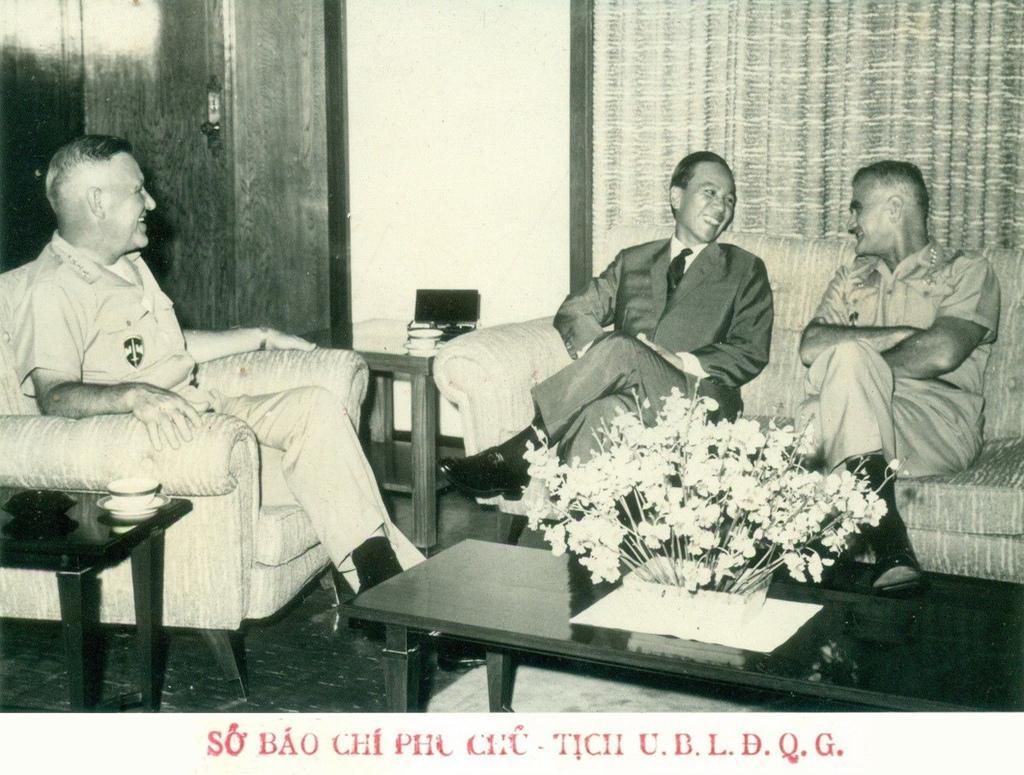Could you give a brief overview of what you see in this image? This picture is clicked inside a room. There are three men sitting on sofa chair. In front of them, we see a table on which flower pot is placed. To the left corner of this picture, we see a table on which cup and saucer is placed. In the middle, the man sitting on the sofa is laughing looking the other man opposite to him. To the right of this man, we see a table on which laptop is placed. Behind him, we see a window with curtain and be beside him, we see a cupboard. 